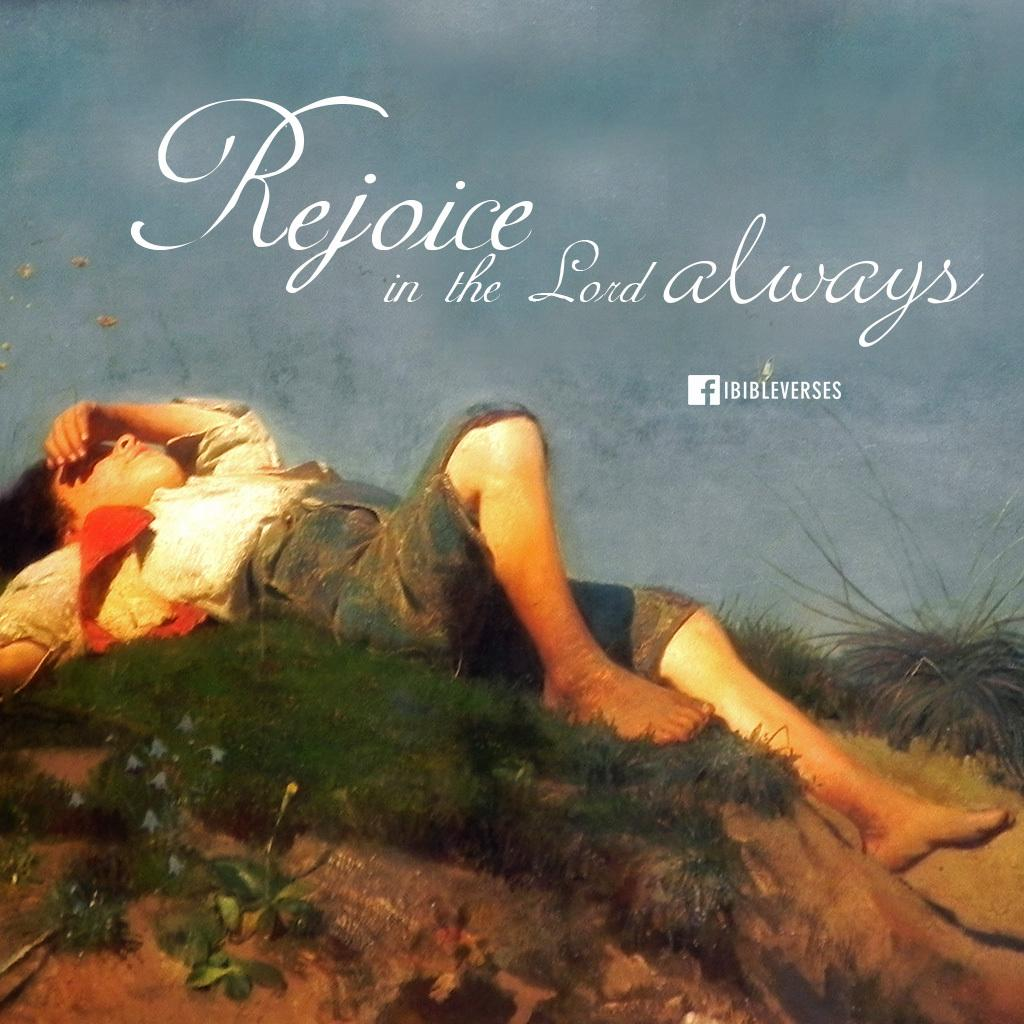Provide a one-sentence caption for the provided image. A religious photo that reads Rejoice in the lord always. 